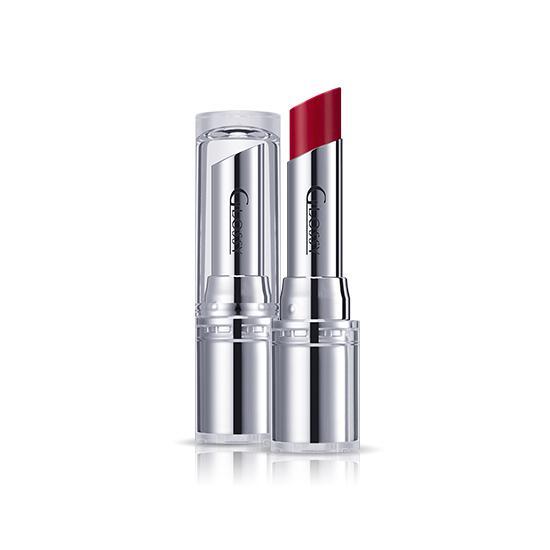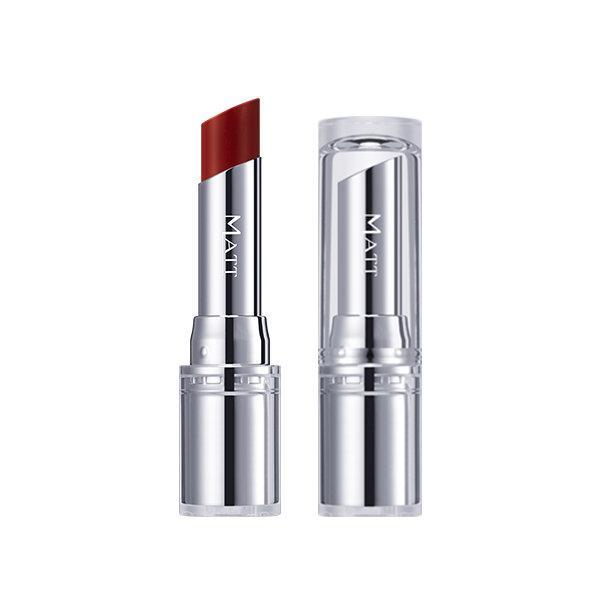The first image is the image on the left, the second image is the image on the right. Evaluate the accuracy of this statement regarding the images: "Each image shows just one lipstick next to its cap.". Is it true? Answer yes or no. Yes. The first image is the image on the left, the second image is the image on the right. Assess this claim about the two images: "The lipstick in the right photo has a black case.". Correct or not? Answer yes or no. No. 